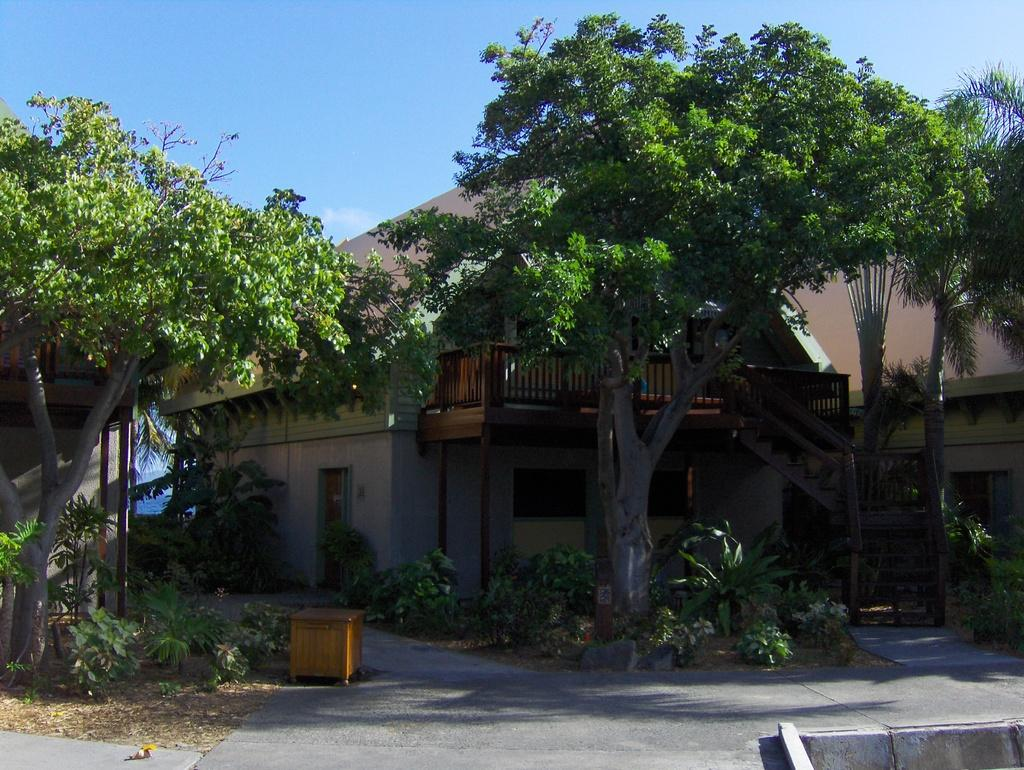What is located in the center of the picture? There are trees, plants, dry leaves, and a building in the center of the picture. What else can be seen in the center of the picture? Other objects are visible in the center of the picture. What is the surface in the foreground of the image? The foreground of the image consists of pavement. How is the weather in the image? The sky is sunny in the image. How many cats are visible in the image? There are no cats present in the image. What type of wound can be seen on the tree in the image? There are no wounds visible on the trees in the image. 